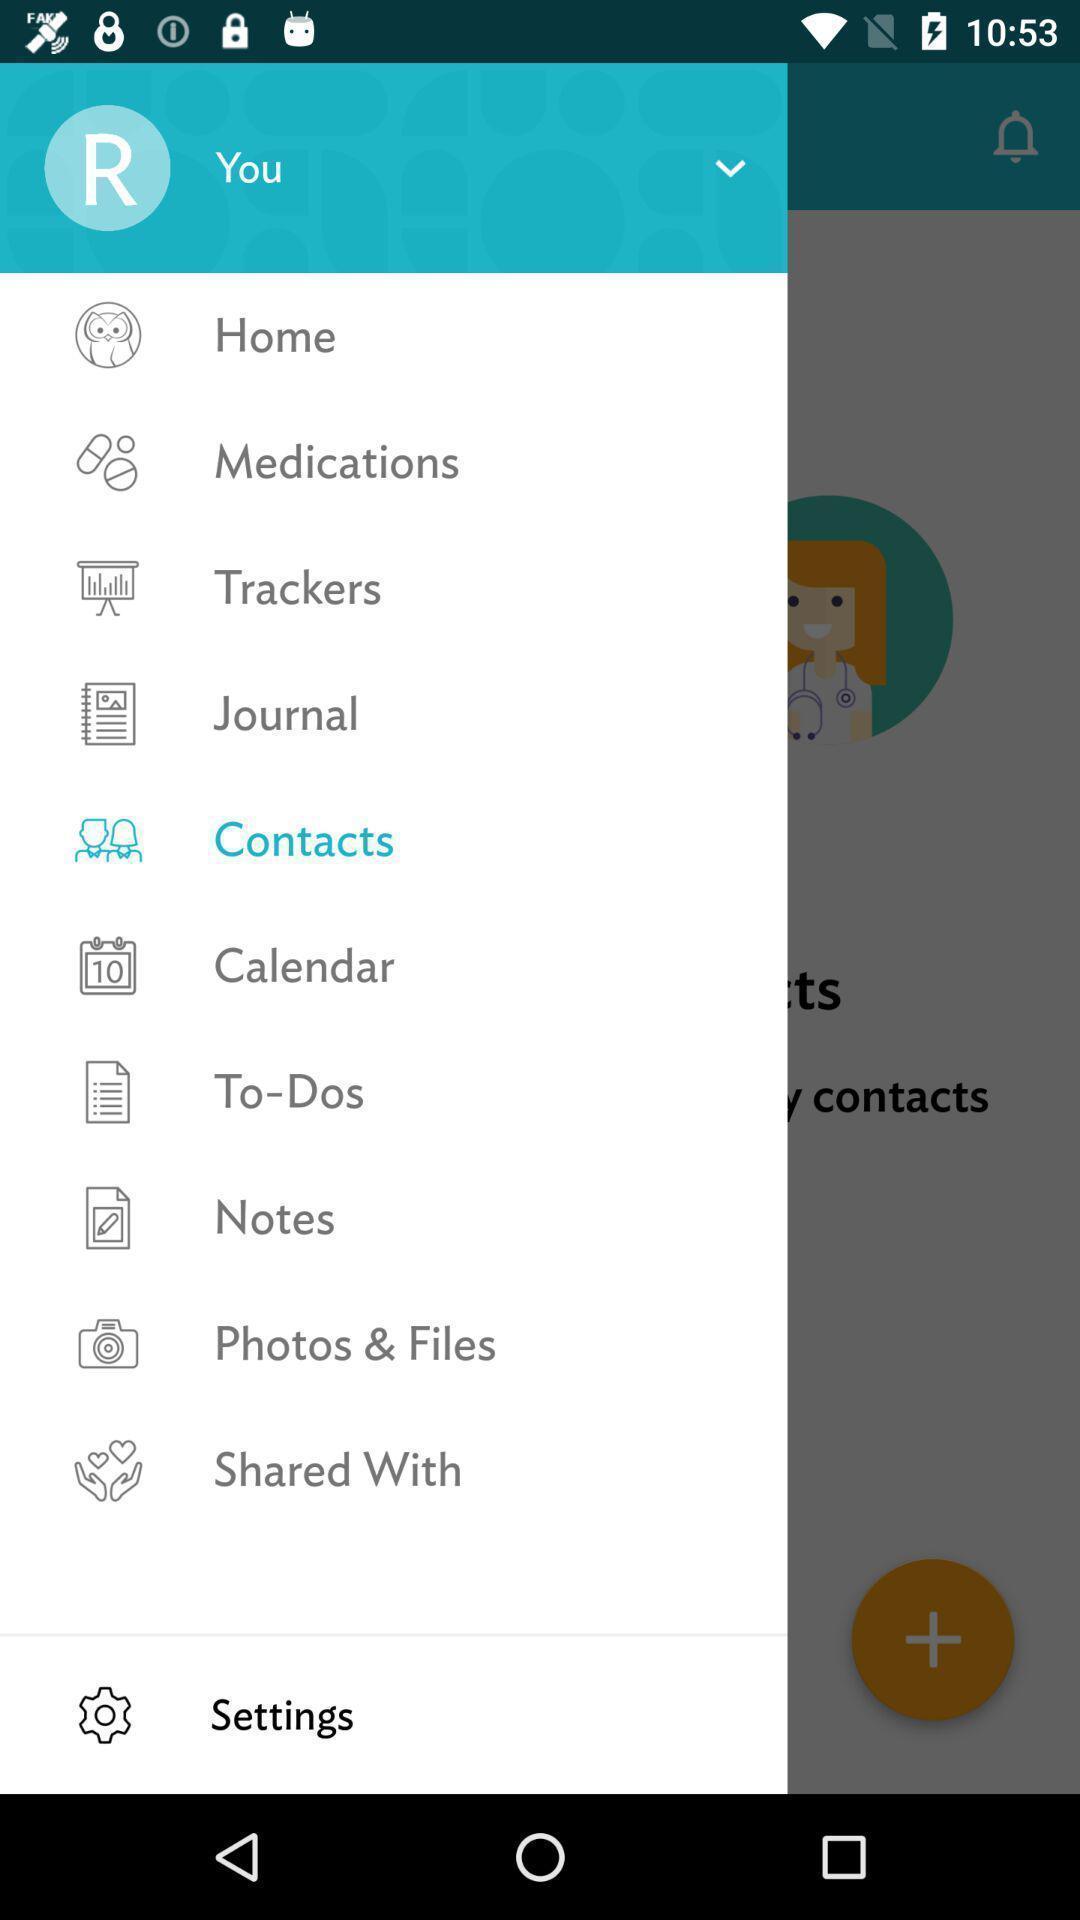Describe the content in this image. Page showing the option menu tab. 